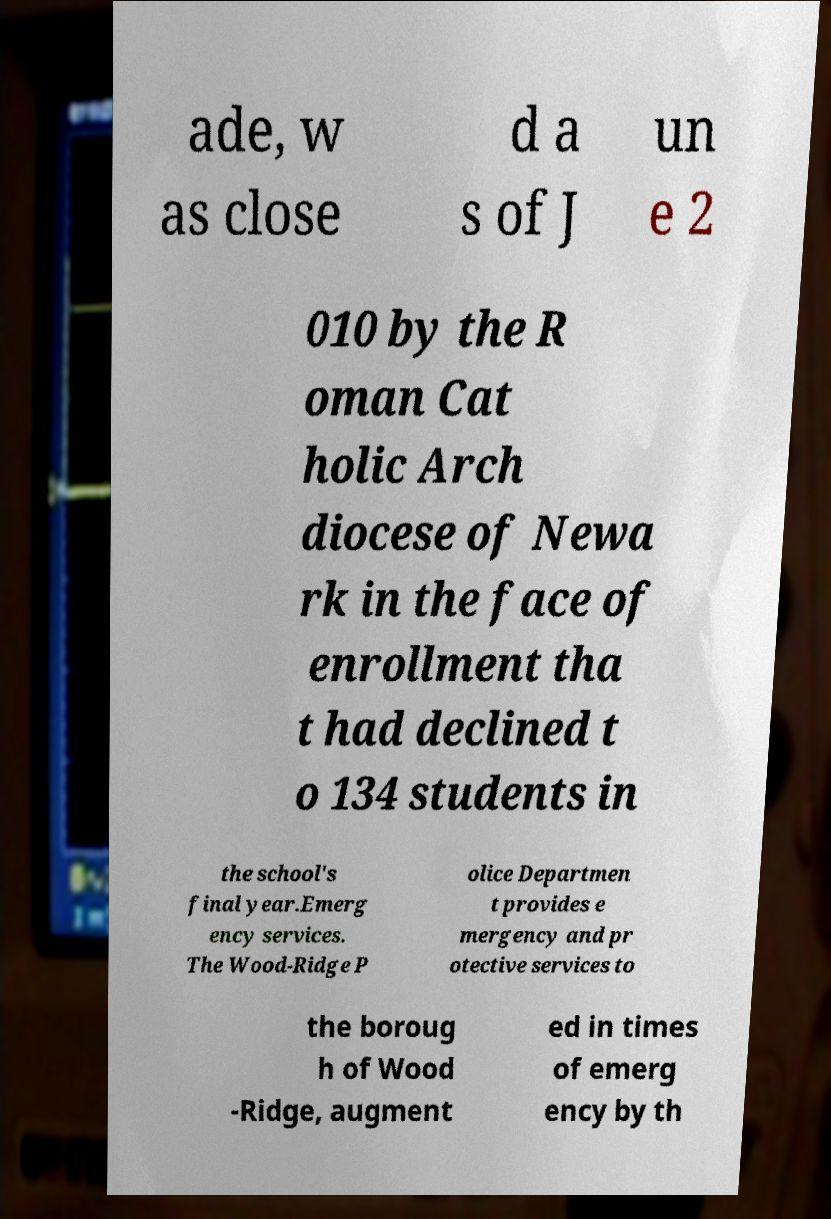Could you extract and type out the text from this image? ade, w as close d a s of J un e 2 010 by the R oman Cat holic Arch diocese of Newa rk in the face of enrollment tha t had declined t o 134 students in the school's final year.Emerg ency services. The Wood-Ridge P olice Departmen t provides e mergency and pr otective services to the boroug h of Wood -Ridge, augment ed in times of emerg ency by th 